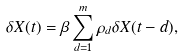Convert formula to latex. <formula><loc_0><loc_0><loc_500><loc_500>\delta X ( t ) = \beta \sum _ { d = 1 } ^ { m } \rho _ { d } \delta X ( t - d ) ,</formula> 